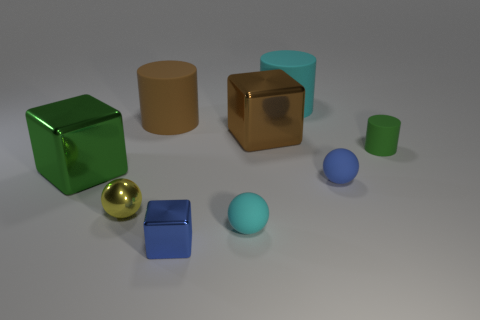Does the small thing behind the green cube have the same shape as the big green thing?
Give a very brief answer. No. What is the shape of the large rubber thing to the right of the tiny rubber object on the left side of the cyan object that is behind the small green rubber cylinder?
Ensure brevity in your answer.  Cylinder. What is the material of the cyan object in front of the large cyan cylinder?
Provide a short and direct response. Rubber. What color is the other cylinder that is the same size as the brown rubber cylinder?
Your response must be concise. Cyan. What number of other objects are the same shape as the big green metal thing?
Offer a very short reply. 2. Is the size of the cyan rubber cylinder the same as the cyan matte ball?
Your answer should be compact. No. Is the number of blue matte balls that are behind the big brown matte object greater than the number of large rubber cylinders on the right side of the large brown shiny cube?
Provide a succinct answer. No. How many other objects are the same size as the yellow thing?
Provide a short and direct response. 4. Does the big object in front of the large brown cube have the same color as the small cube?
Make the answer very short. No. Is the number of matte things that are behind the small cyan ball greater than the number of small green rubber spheres?
Offer a terse response. Yes. 